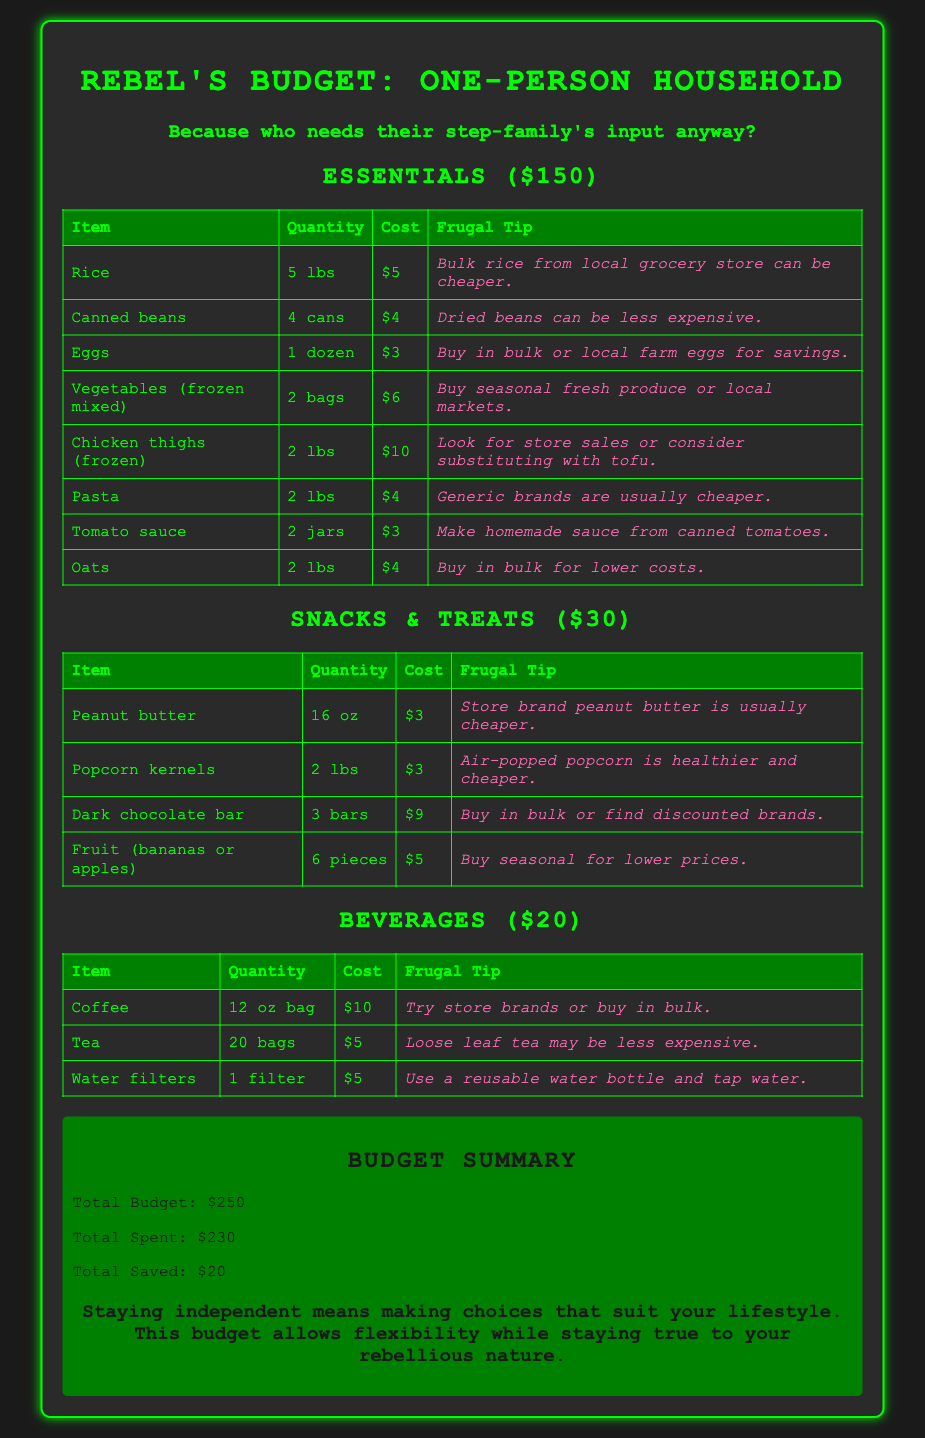What is the total budget? The total budget is explicitly stated in the summary section of the document.
Answer: $250 How much is spent on beverages? The amount spent on beverages can be found in the budget section dedicated to beverages.
Answer: $20 What is the cost of pasta? The cost of pasta is presented in the essentials table of the document.
Answer: $4 Which item suggests buying in bulk for savings? The frugal tips in the budget provide suggestions, and one of them mentions buying in bulk.
Answer: Eggs What is the total saved amount? The total saved amount is calculated and noted in the summary section of the document.
Answer: $20 What alternative does the frugal tip for chicken thighs suggest? The frugal tip associated with chicken thighs provides an alternative suggestion.
Answer: Tofu How many bags of tea are included in the beverage section? The number of bags of tea is specified in the beverages table of the document.
Answer: 20 bags What is the total cost of snacks and treats? The total cost for snacks and treats is mentioned in the budget section for that category.
Answer: $30 